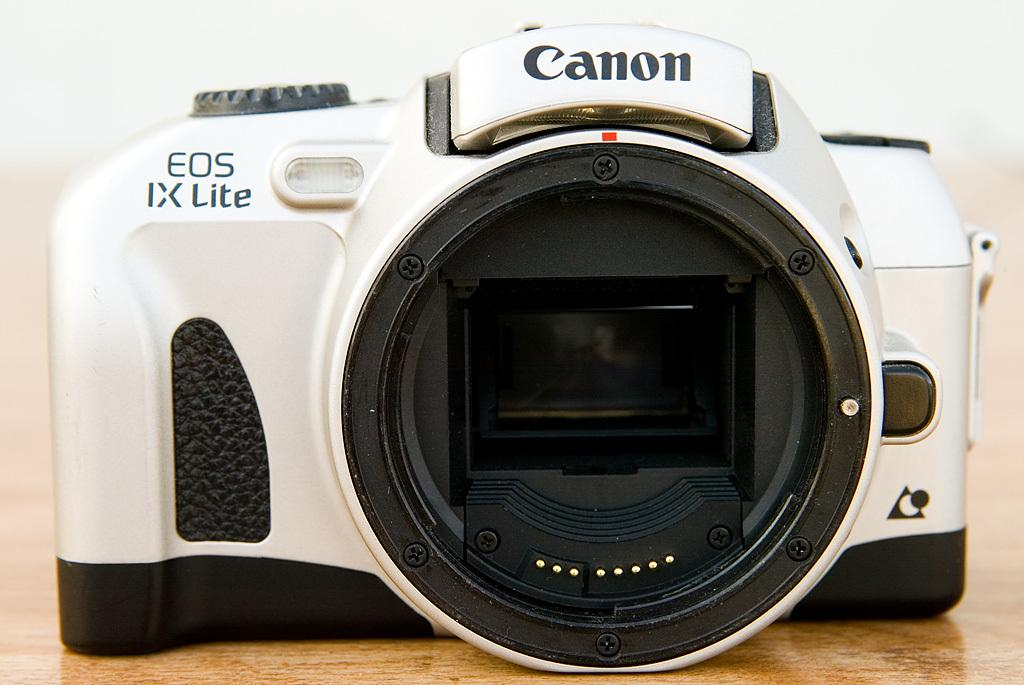<image>
Create a compact narrative representing the image presented. A white canon branded digital camera with a wide lens. 